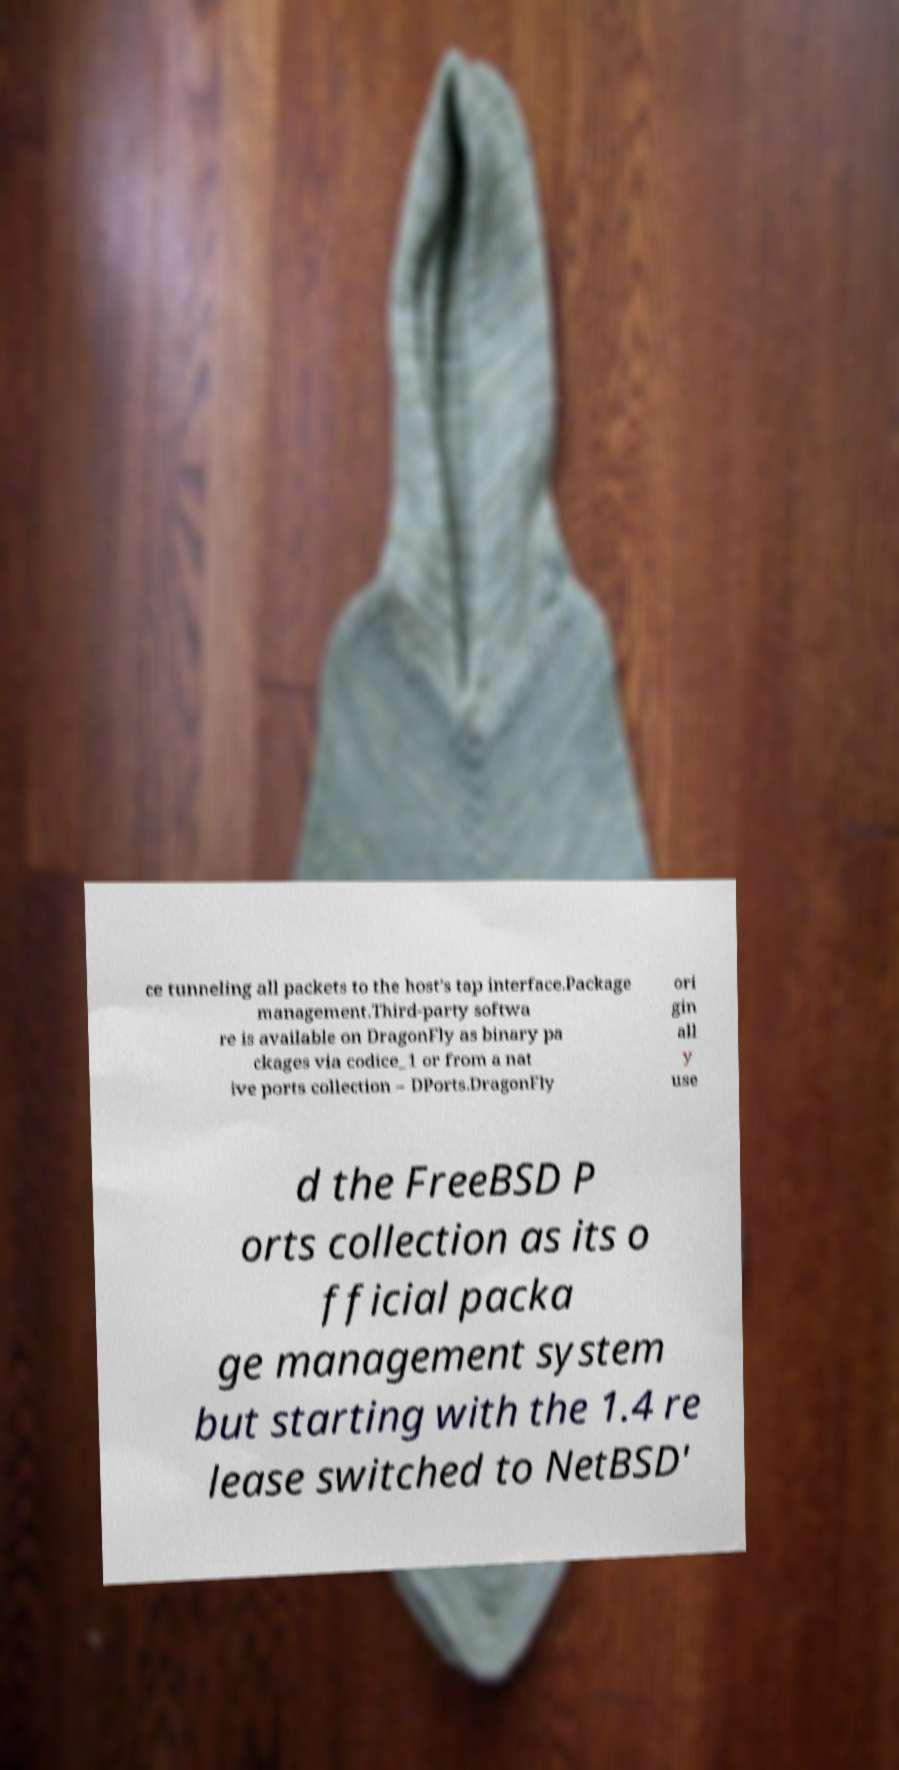Can you read and provide the text displayed in the image?This photo seems to have some interesting text. Can you extract and type it out for me? ce tunneling all packets to the host's tap interface.Package management.Third-party softwa re is available on DragonFly as binary pa ckages via codice_1 or from a nat ive ports collection – DPorts.DragonFly ori gin all y use d the FreeBSD P orts collection as its o fficial packa ge management system but starting with the 1.4 re lease switched to NetBSD' 